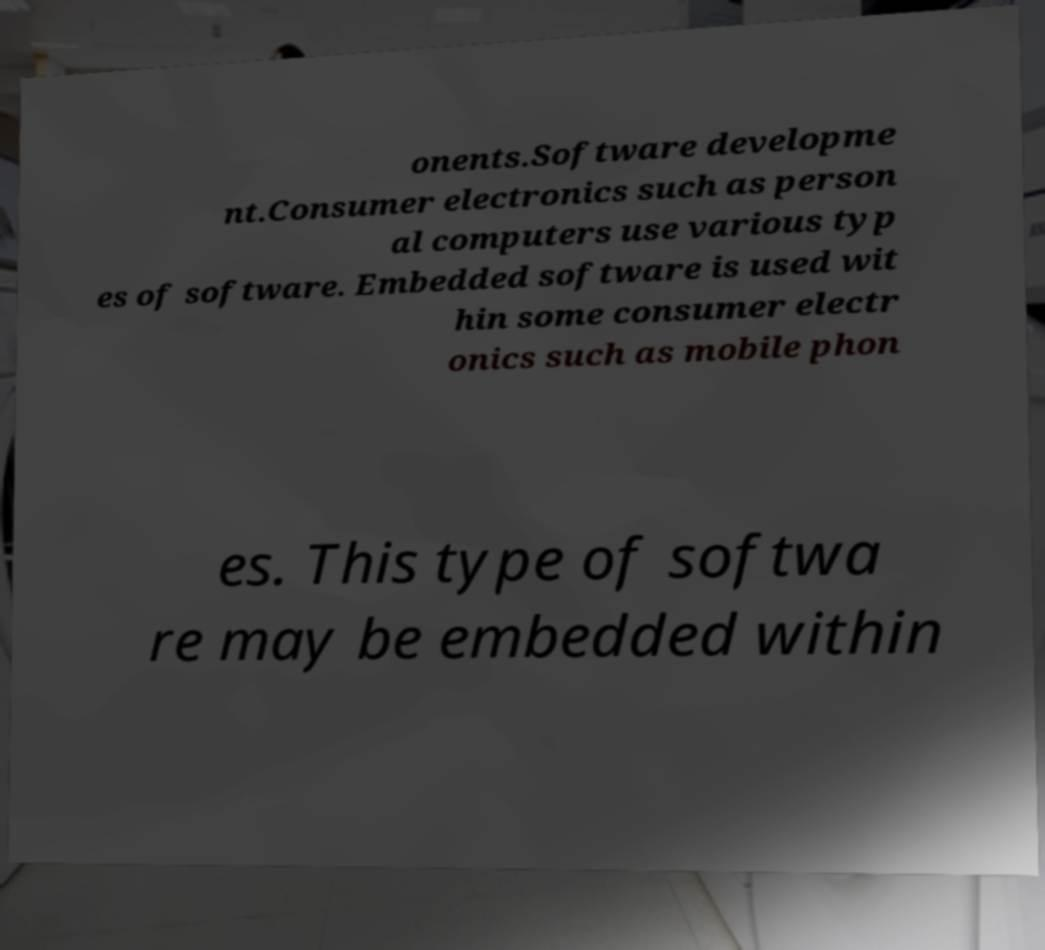Can you read and provide the text displayed in the image?This photo seems to have some interesting text. Can you extract and type it out for me? onents.Software developme nt.Consumer electronics such as person al computers use various typ es of software. Embedded software is used wit hin some consumer electr onics such as mobile phon es. This type of softwa re may be embedded within 